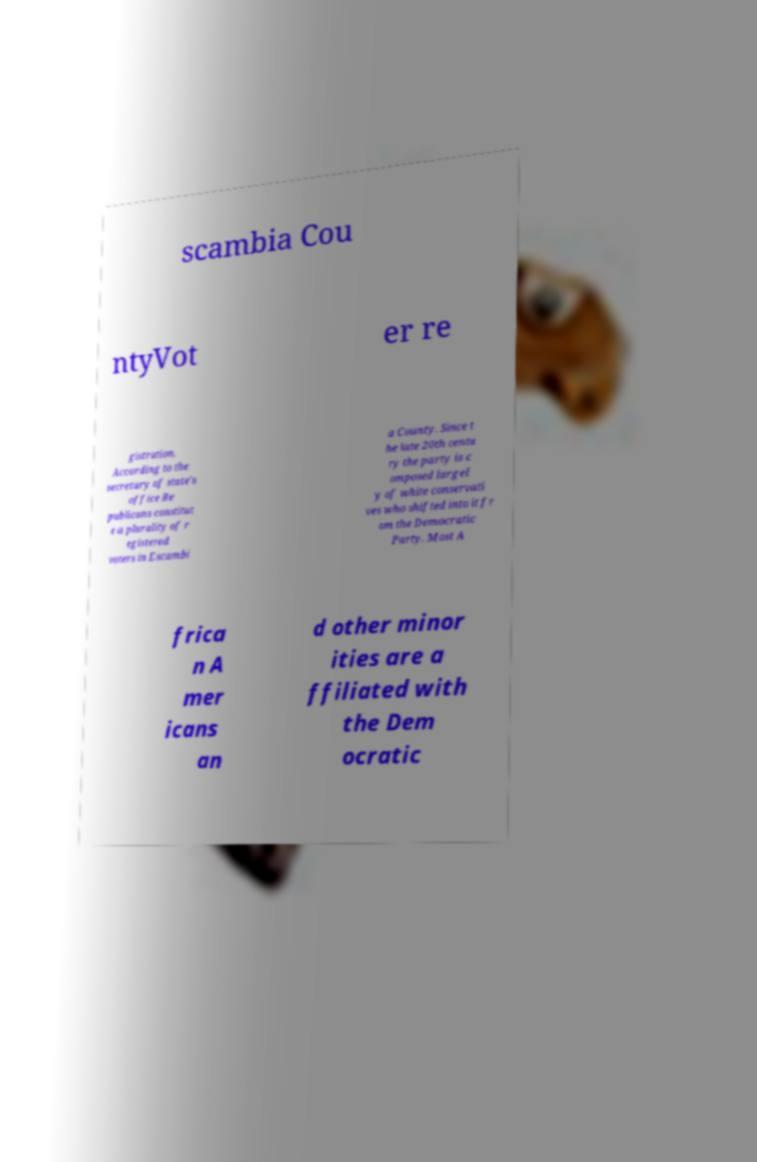For documentation purposes, I need the text within this image transcribed. Could you provide that? scambia Cou ntyVot er re gistration. According to the secretary of state's office Re publicans constitut e a plurality of r egistered voters in Escambi a County. Since t he late 20th centu ry the party is c omposed largel y of white conservati ves who shifted into it fr om the Democratic Party. Most A frica n A mer icans an d other minor ities are a ffiliated with the Dem ocratic 